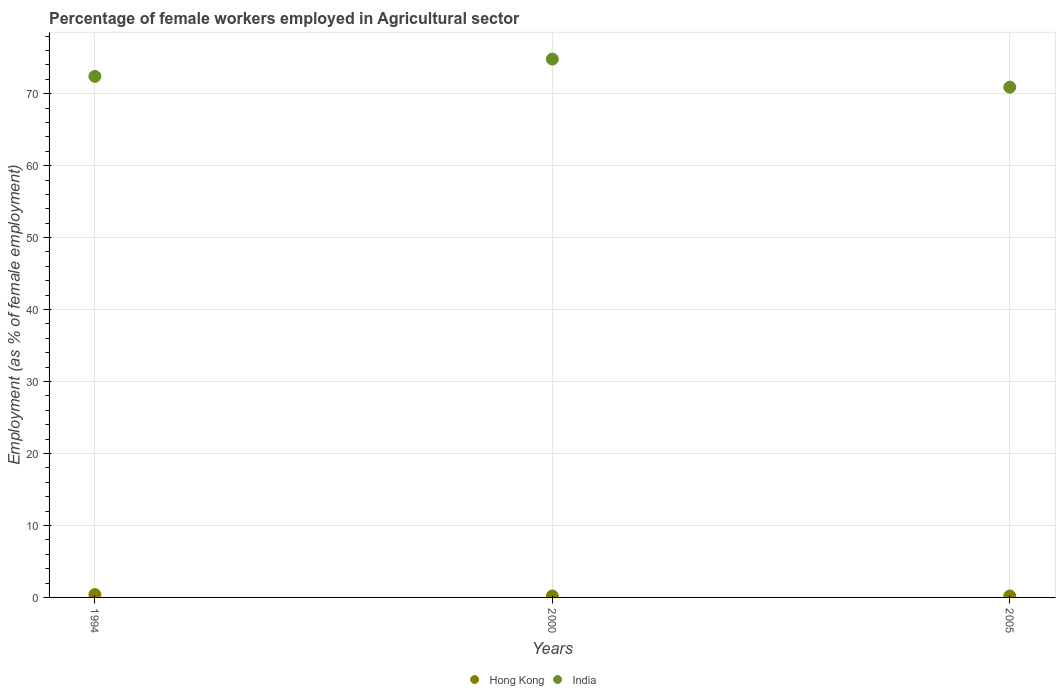How many different coloured dotlines are there?
Ensure brevity in your answer.  2. Is the number of dotlines equal to the number of legend labels?
Provide a short and direct response. Yes. What is the percentage of females employed in Agricultural sector in Hong Kong in 2000?
Your response must be concise. 0.2. Across all years, what is the maximum percentage of females employed in Agricultural sector in Hong Kong?
Your answer should be compact. 0.4. Across all years, what is the minimum percentage of females employed in Agricultural sector in India?
Offer a terse response. 70.9. In which year was the percentage of females employed in Agricultural sector in Hong Kong maximum?
Provide a succinct answer. 1994. What is the total percentage of females employed in Agricultural sector in India in the graph?
Keep it short and to the point. 218.1. What is the difference between the percentage of females employed in Agricultural sector in India in 2000 and that in 2005?
Keep it short and to the point. 3.9. What is the difference between the percentage of females employed in Agricultural sector in Hong Kong in 1994 and the percentage of females employed in Agricultural sector in India in 2000?
Your response must be concise. -74.4. What is the average percentage of females employed in Agricultural sector in India per year?
Ensure brevity in your answer.  72.7. In the year 2005, what is the difference between the percentage of females employed in Agricultural sector in India and percentage of females employed in Agricultural sector in Hong Kong?
Keep it short and to the point. 70.7. In how many years, is the percentage of females employed in Agricultural sector in Hong Kong greater than 16 %?
Offer a very short reply. 0. What is the ratio of the percentage of females employed in Agricultural sector in India in 2000 to that in 2005?
Ensure brevity in your answer.  1.06. Is the difference between the percentage of females employed in Agricultural sector in India in 1994 and 2000 greater than the difference between the percentage of females employed in Agricultural sector in Hong Kong in 1994 and 2000?
Keep it short and to the point. No. What is the difference between the highest and the second highest percentage of females employed in Agricultural sector in Hong Kong?
Your response must be concise. 0.2. What is the difference between the highest and the lowest percentage of females employed in Agricultural sector in India?
Your answer should be very brief. 3.9. In how many years, is the percentage of females employed in Agricultural sector in India greater than the average percentage of females employed in Agricultural sector in India taken over all years?
Provide a succinct answer. 1. Is the sum of the percentage of females employed in Agricultural sector in Hong Kong in 2000 and 2005 greater than the maximum percentage of females employed in Agricultural sector in India across all years?
Offer a terse response. No. Does the percentage of females employed in Agricultural sector in India monotonically increase over the years?
Ensure brevity in your answer.  No. Is the percentage of females employed in Agricultural sector in India strictly less than the percentage of females employed in Agricultural sector in Hong Kong over the years?
Provide a succinct answer. No. Are the values on the major ticks of Y-axis written in scientific E-notation?
Ensure brevity in your answer.  No. Does the graph contain any zero values?
Ensure brevity in your answer.  No. How many legend labels are there?
Offer a terse response. 2. How are the legend labels stacked?
Your answer should be very brief. Horizontal. What is the title of the graph?
Your answer should be very brief. Percentage of female workers employed in Agricultural sector. Does "Singapore" appear as one of the legend labels in the graph?
Offer a very short reply. No. What is the label or title of the X-axis?
Your response must be concise. Years. What is the label or title of the Y-axis?
Keep it short and to the point. Employment (as % of female employment). What is the Employment (as % of female employment) of Hong Kong in 1994?
Give a very brief answer. 0.4. What is the Employment (as % of female employment) of India in 1994?
Give a very brief answer. 72.4. What is the Employment (as % of female employment) in Hong Kong in 2000?
Make the answer very short. 0.2. What is the Employment (as % of female employment) in India in 2000?
Your response must be concise. 74.8. What is the Employment (as % of female employment) in Hong Kong in 2005?
Provide a succinct answer. 0.2. What is the Employment (as % of female employment) in India in 2005?
Provide a short and direct response. 70.9. Across all years, what is the maximum Employment (as % of female employment) in Hong Kong?
Make the answer very short. 0.4. Across all years, what is the maximum Employment (as % of female employment) of India?
Your answer should be compact. 74.8. Across all years, what is the minimum Employment (as % of female employment) in Hong Kong?
Keep it short and to the point. 0.2. Across all years, what is the minimum Employment (as % of female employment) of India?
Offer a terse response. 70.9. What is the total Employment (as % of female employment) of Hong Kong in the graph?
Keep it short and to the point. 0.8. What is the total Employment (as % of female employment) of India in the graph?
Offer a very short reply. 218.1. What is the difference between the Employment (as % of female employment) of Hong Kong in 1994 and that in 2000?
Offer a terse response. 0.2. What is the difference between the Employment (as % of female employment) in Hong Kong in 2000 and that in 2005?
Make the answer very short. 0. What is the difference between the Employment (as % of female employment) in Hong Kong in 1994 and the Employment (as % of female employment) in India in 2000?
Keep it short and to the point. -74.4. What is the difference between the Employment (as % of female employment) in Hong Kong in 1994 and the Employment (as % of female employment) in India in 2005?
Your answer should be compact. -70.5. What is the difference between the Employment (as % of female employment) of Hong Kong in 2000 and the Employment (as % of female employment) of India in 2005?
Provide a succinct answer. -70.7. What is the average Employment (as % of female employment) in Hong Kong per year?
Provide a short and direct response. 0.27. What is the average Employment (as % of female employment) in India per year?
Your response must be concise. 72.7. In the year 1994, what is the difference between the Employment (as % of female employment) of Hong Kong and Employment (as % of female employment) of India?
Your response must be concise. -72. In the year 2000, what is the difference between the Employment (as % of female employment) of Hong Kong and Employment (as % of female employment) of India?
Your response must be concise. -74.6. In the year 2005, what is the difference between the Employment (as % of female employment) in Hong Kong and Employment (as % of female employment) in India?
Give a very brief answer. -70.7. What is the ratio of the Employment (as % of female employment) of India in 1994 to that in 2000?
Provide a succinct answer. 0.97. What is the ratio of the Employment (as % of female employment) in Hong Kong in 1994 to that in 2005?
Provide a short and direct response. 2. What is the ratio of the Employment (as % of female employment) of India in 1994 to that in 2005?
Make the answer very short. 1.02. What is the ratio of the Employment (as % of female employment) in India in 2000 to that in 2005?
Your response must be concise. 1.05. What is the difference between the highest and the lowest Employment (as % of female employment) in Hong Kong?
Your answer should be compact. 0.2. 